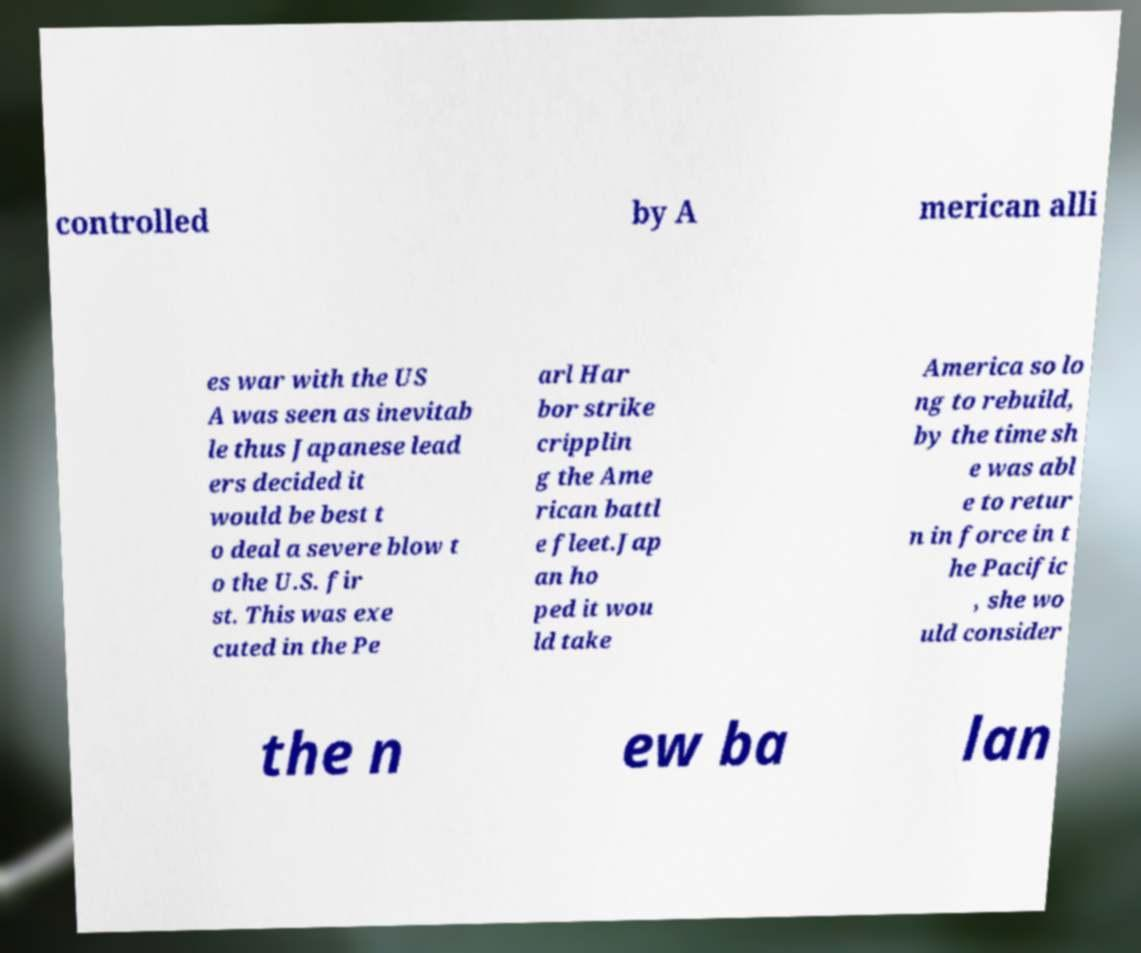Could you assist in decoding the text presented in this image and type it out clearly? controlled by A merican alli es war with the US A was seen as inevitab le thus Japanese lead ers decided it would be best t o deal a severe blow t o the U.S. fir st. This was exe cuted in the Pe arl Har bor strike cripplin g the Ame rican battl e fleet.Jap an ho ped it wou ld take America so lo ng to rebuild, by the time sh e was abl e to retur n in force in t he Pacific , she wo uld consider the n ew ba lan 